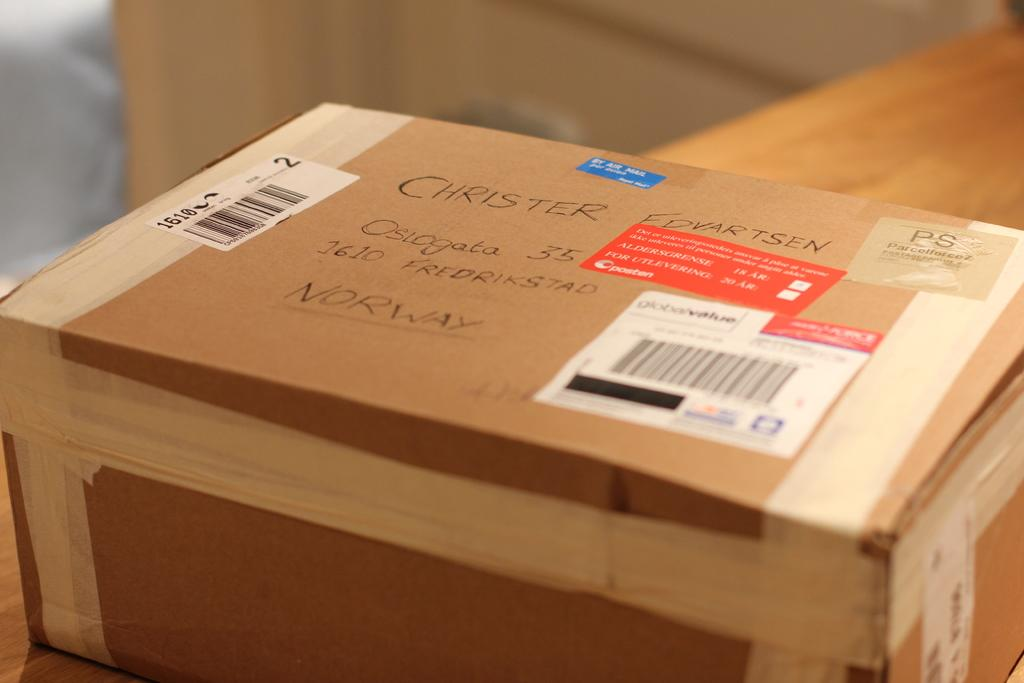Provide a one-sentence caption for the provided image. a box with labels on it addressed to Christer Edvartsen. 